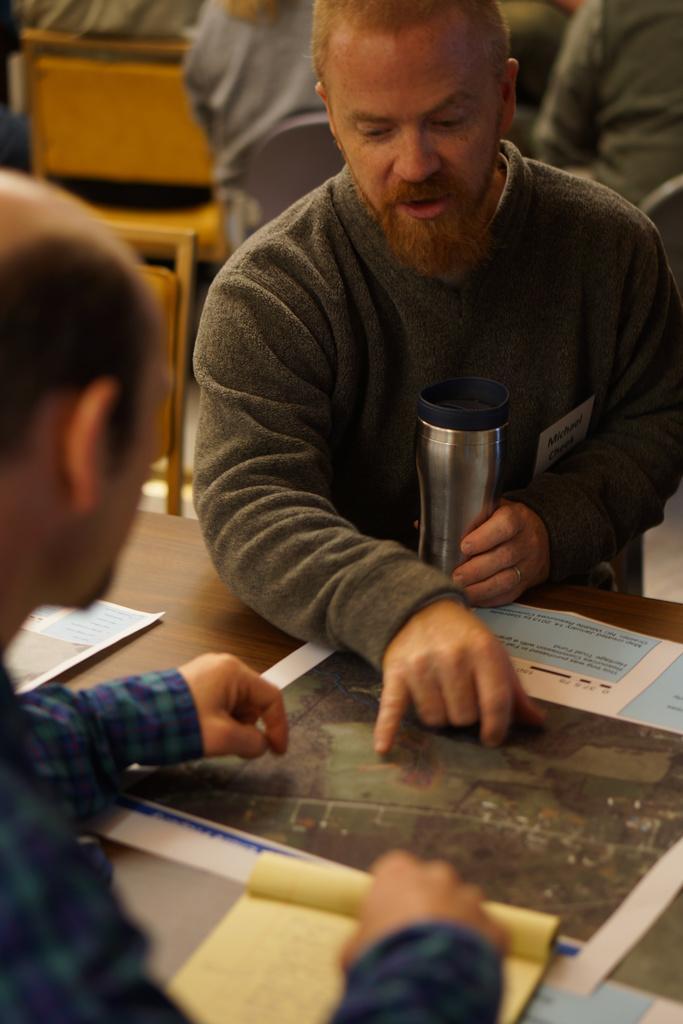Describe this image in one or two sentences. In this image we can see group of persons sitting on chairs. One person is holding a bottle with his hand. In the foreground we can see a map, paper and a book placed on the table. 